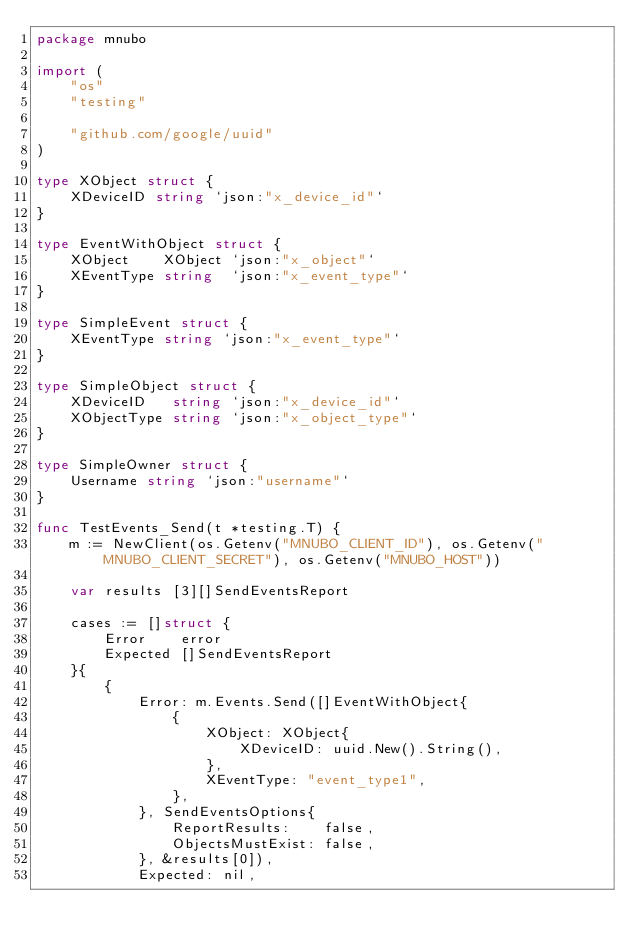Convert code to text. <code><loc_0><loc_0><loc_500><loc_500><_Go_>package mnubo

import (
	"os"
	"testing"

	"github.com/google/uuid"
)

type XObject struct {
	XDeviceID string `json:"x_device_id"`
}

type EventWithObject struct {
	XObject    XObject `json:"x_object"`
	XEventType string  `json:"x_event_type"`
}

type SimpleEvent struct {
	XEventType string `json:"x_event_type"`
}

type SimpleObject struct {
	XDeviceID   string `json:"x_device_id"`
	XObjectType string `json:"x_object_type"`
}

type SimpleOwner struct {
	Username string `json:"username"`
}

func TestEvents_Send(t *testing.T) {
	m := NewClient(os.Getenv("MNUBO_CLIENT_ID"), os.Getenv("MNUBO_CLIENT_SECRET"), os.Getenv("MNUBO_HOST"))

	var results [3][]SendEventsReport

	cases := []struct {
		Error    error
		Expected []SendEventsReport
	}{
		{
			Error: m.Events.Send([]EventWithObject{
				{
					XObject: XObject{
						XDeviceID: uuid.New().String(),
					},
					XEventType: "event_type1",
				},
			}, SendEventsOptions{
				ReportResults:    false,
				ObjectsMustExist: false,
			}, &results[0]),
			Expected: nil,</code> 